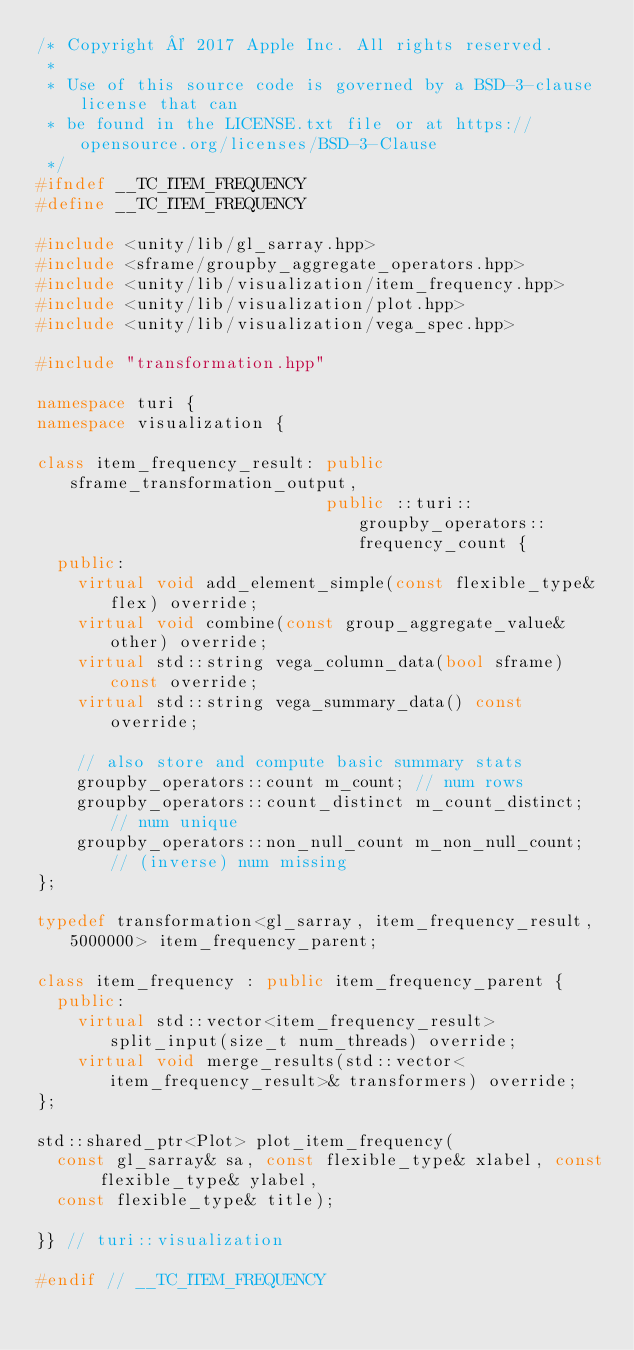Convert code to text. <code><loc_0><loc_0><loc_500><loc_500><_C++_>/* Copyright © 2017 Apple Inc. All rights reserved.
 *
 * Use of this source code is governed by a BSD-3-clause license that can
 * be found in the LICENSE.txt file or at https://opensource.org/licenses/BSD-3-Clause
 */
#ifndef __TC_ITEM_FREQUENCY
#define __TC_ITEM_FREQUENCY

#include <unity/lib/gl_sarray.hpp>
#include <sframe/groupby_aggregate_operators.hpp>
#include <unity/lib/visualization/item_frequency.hpp>
#include <unity/lib/visualization/plot.hpp>
#include <unity/lib/visualization/vega_spec.hpp>

#include "transformation.hpp"

namespace turi {
namespace visualization {

class item_frequency_result: public sframe_transformation_output,
                             public ::turi::groupby_operators::frequency_count {
  public:
    virtual void add_element_simple(const flexible_type& flex) override;
    virtual void combine(const group_aggregate_value& other) override;
    virtual std::string vega_column_data(bool sframe) const override;
    virtual std::string vega_summary_data() const override;

    // also store and compute basic summary stats
    groupby_operators::count m_count; // num rows
    groupby_operators::count_distinct m_count_distinct; // num unique
    groupby_operators::non_null_count m_non_null_count; // (inverse) num missing
};

typedef transformation<gl_sarray, item_frequency_result, 5000000> item_frequency_parent;

class item_frequency : public item_frequency_parent {
  public:
    virtual std::vector<item_frequency_result> split_input(size_t num_threads) override;
    virtual void merge_results(std::vector<item_frequency_result>& transformers) override;
};

std::shared_ptr<Plot> plot_item_frequency(
  const gl_sarray& sa, const flexible_type& xlabel, const flexible_type& ylabel, 
  const flexible_type& title);

}} // turi::visualization

#endif // __TC_ITEM_FREQUENCY
</code> 